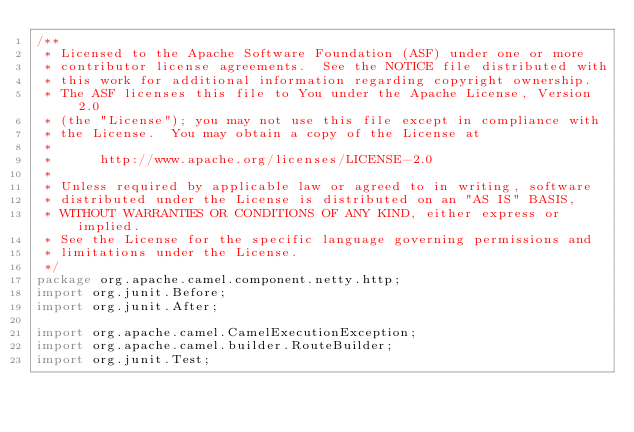Convert code to text. <code><loc_0><loc_0><loc_500><loc_500><_Java_>/**
 * Licensed to the Apache Software Foundation (ASF) under one or more
 * contributor license agreements.  See the NOTICE file distributed with
 * this work for additional information regarding copyright ownership.
 * The ASF licenses this file to You under the Apache License, Version 2.0
 * (the "License"); you may not use this file except in compliance with
 * the License.  You may obtain a copy of the License at
 *
 *      http://www.apache.org/licenses/LICENSE-2.0
 *
 * Unless required by applicable law or agreed to in writing, software
 * distributed under the License is distributed on an "AS IS" BASIS,
 * WITHOUT WARRANTIES OR CONDITIONS OF ANY KIND, either express or implied.
 * See the License for the specific language governing permissions and
 * limitations under the License.
 */
package org.apache.camel.component.netty.http;
import org.junit.Before;
import org.junit.After;

import org.apache.camel.CamelExecutionException;
import org.apache.camel.builder.RouteBuilder;
import org.junit.Test;
</code> 